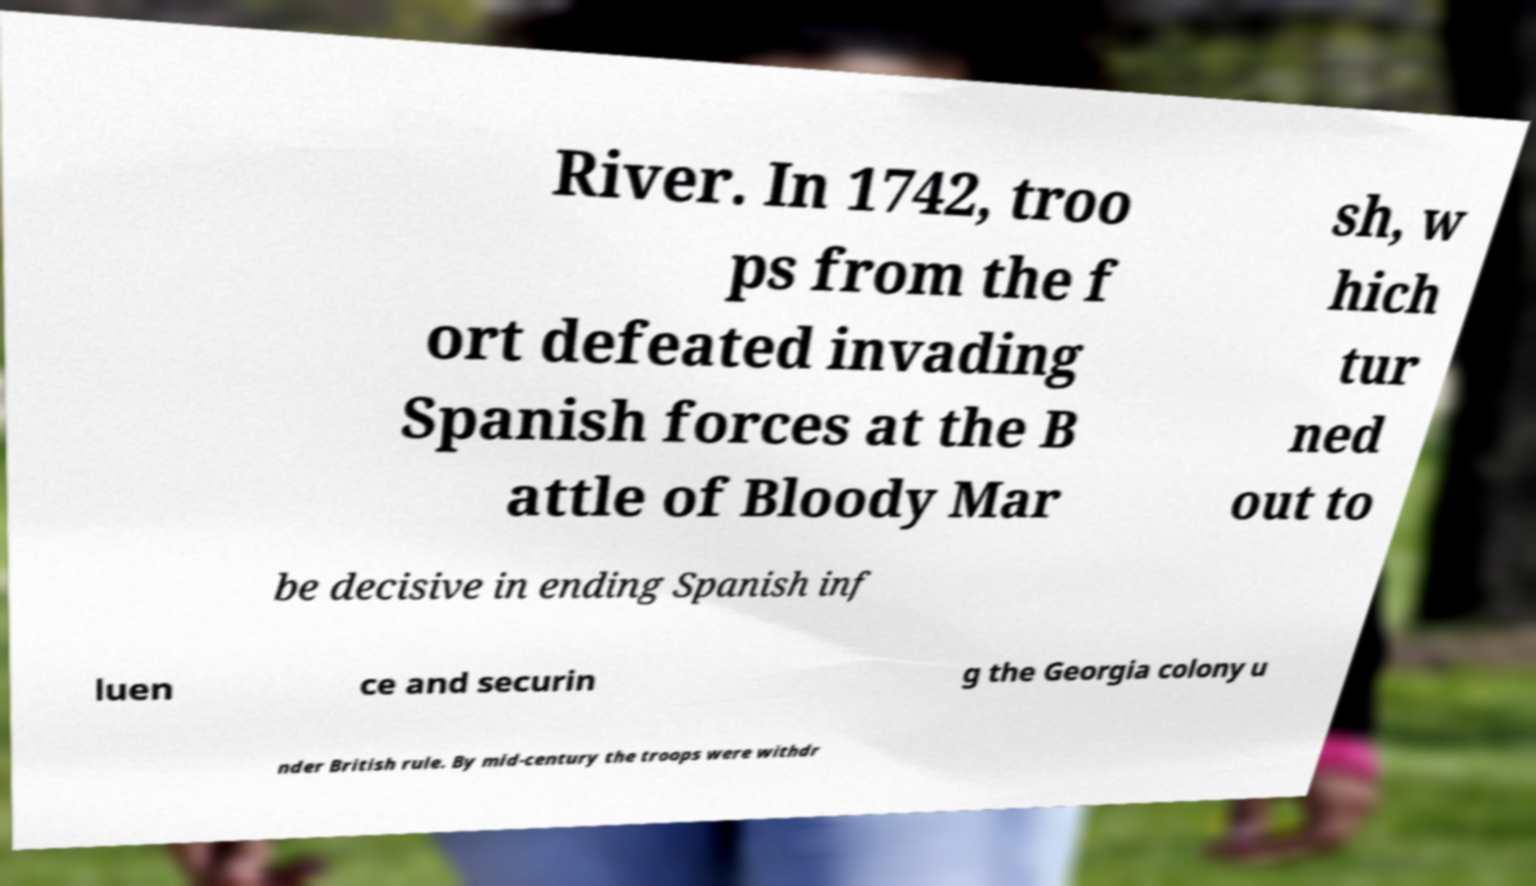Can you read and provide the text displayed in the image?This photo seems to have some interesting text. Can you extract and type it out for me? River. In 1742, troo ps from the f ort defeated invading Spanish forces at the B attle of Bloody Mar sh, w hich tur ned out to be decisive in ending Spanish inf luen ce and securin g the Georgia colony u nder British rule. By mid-century the troops were withdr 